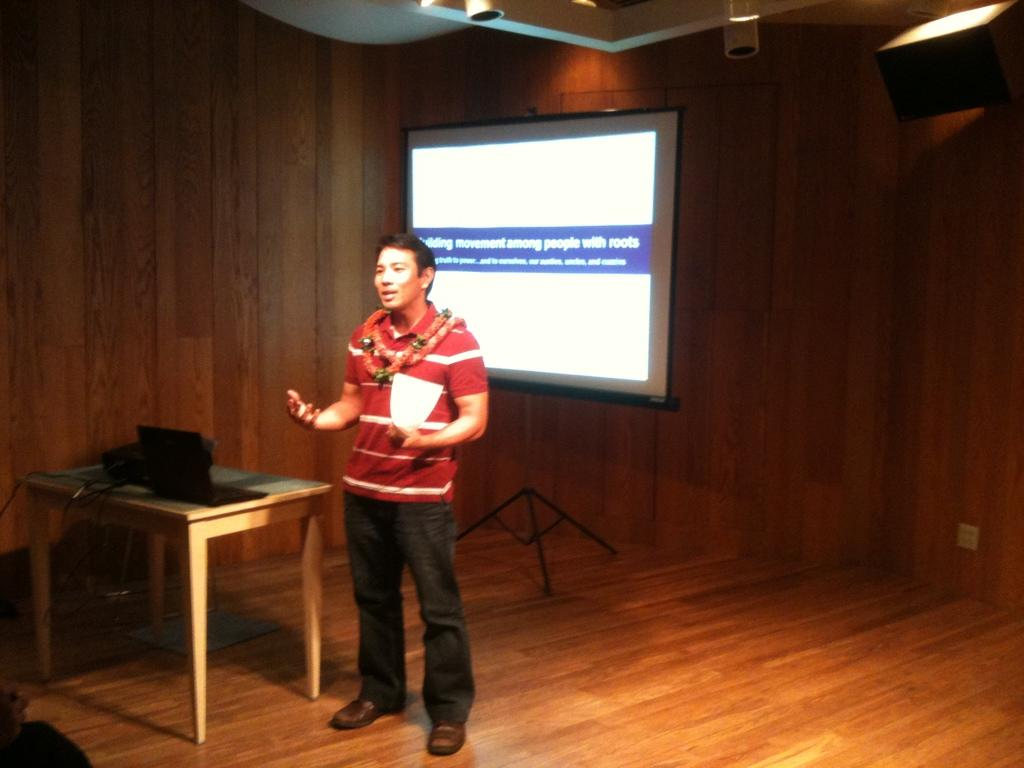Where is the person in the image located? The person is standing on a stage. What is the person holding in the image? The person is holding a paper. What is the person doing in the image? The person is talking. What can be seen on the table in the image? There is a laptop and wires on the table. What is visible in the background of the image? There is a projector on the wall in the background. What type of rice is being cooked in the image? There is no rice present in the image; it is a person standing on a stage, holding a paper, and talking. 